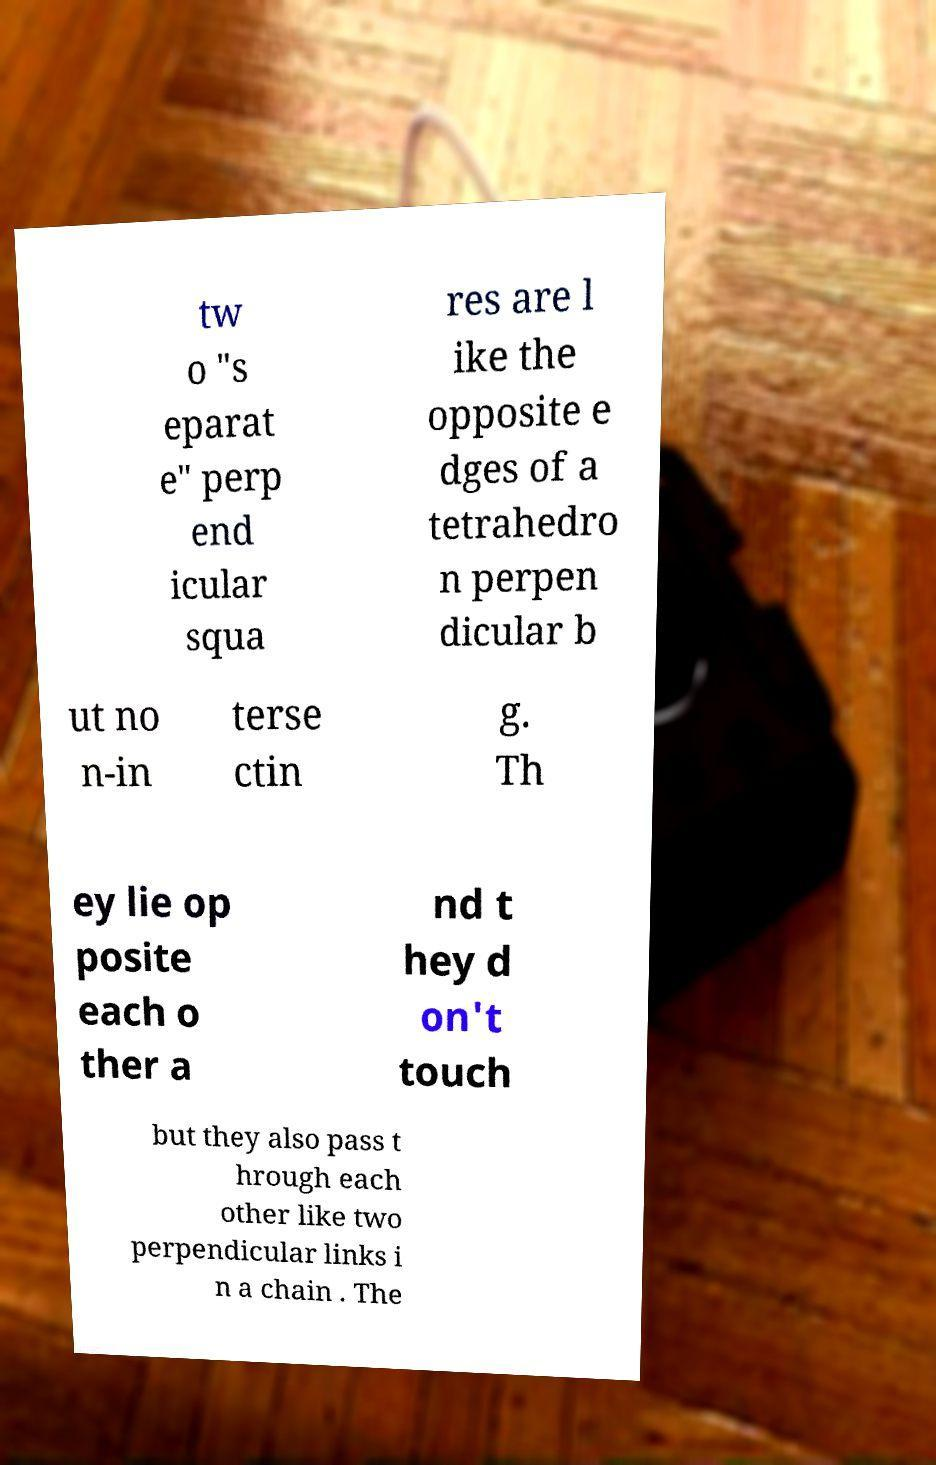What messages or text are displayed in this image? I need them in a readable, typed format. tw o "s eparat e" perp end icular squa res are l ike the opposite e dges of a tetrahedro n perpen dicular b ut no n-in terse ctin g. Th ey lie op posite each o ther a nd t hey d on't touch but they also pass t hrough each other like two perpendicular links i n a chain . The 